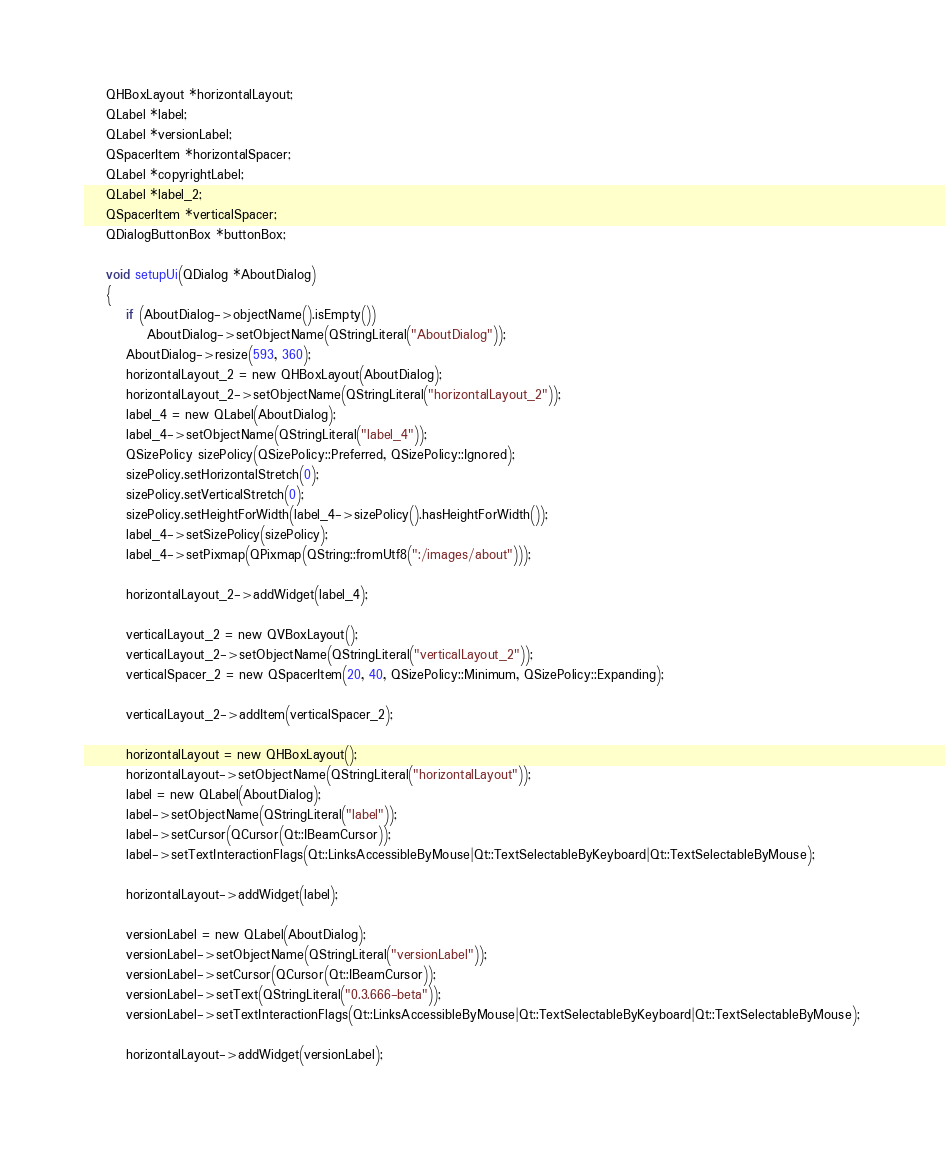Convert code to text. <code><loc_0><loc_0><loc_500><loc_500><_C_>    QHBoxLayout *horizontalLayout;
    QLabel *label;
    QLabel *versionLabel;
    QSpacerItem *horizontalSpacer;
    QLabel *copyrightLabel;
    QLabel *label_2;
    QSpacerItem *verticalSpacer;
    QDialogButtonBox *buttonBox;

    void setupUi(QDialog *AboutDialog)
    {
        if (AboutDialog->objectName().isEmpty())
            AboutDialog->setObjectName(QStringLiteral("AboutDialog"));
        AboutDialog->resize(593, 360);
        horizontalLayout_2 = new QHBoxLayout(AboutDialog);
        horizontalLayout_2->setObjectName(QStringLiteral("horizontalLayout_2"));
        label_4 = new QLabel(AboutDialog);
        label_4->setObjectName(QStringLiteral("label_4"));
        QSizePolicy sizePolicy(QSizePolicy::Preferred, QSizePolicy::Ignored);
        sizePolicy.setHorizontalStretch(0);
        sizePolicy.setVerticalStretch(0);
        sizePolicy.setHeightForWidth(label_4->sizePolicy().hasHeightForWidth());
        label_4->setSizePolicy(sizePolicy);
        label_4->setPixmap(QPixmap(QString::fromUtf8(":/images/about")));

        horizontalLayout_2->addWidget(label_4);

        verticalLayout_2 = new QVBoxLayout();
        verticalLayout_2->setObjectName(QStringLiteral("verticalLayout_2"));
        verticalSpacer_2 = new QSpacerItem(20, 40, QSizePolicy::Minimum, QSizePolicy::Expanding);

        verticalLayout_2->addItem(verticalSpacer_2);

        horizontalLayout = new QHBoxLayout();
        horizontalLayout->setObjectName(QStringLiteral("horizontalLayout"));
        label = new QLabel(AboutDialog);
        label->setObjectName(QStringLiteral("label"));
        label->setCursor(QCursor(Qt::IBeamCursor));
        label->setTextInteractionFlags(Qt::LinksAccessibleByMouse|Qt::TextSelectableByKeyboard|Qt::TextSelectableByMouse);

        horizontalLayout->addWidget(label);

        versionLabel = new QLabel(AboutDialog);
        versionLabel->setObjectName(QStringLiteral("versionLabel"));
        versionLabel->setCursor(QCursor(Qt::IBeamCursor));
        versionLabel->setText(QStringLiteral("0.3.666-beta"));
        versionLabel->setTextInteractionFlags(Qt::LinksAccessibleByMouse|Qt::TextSelectableByKeyboard|Qt::TextSelectableByMouse);

        horizontalLayout->addWidget(versionLabel);
</code> 